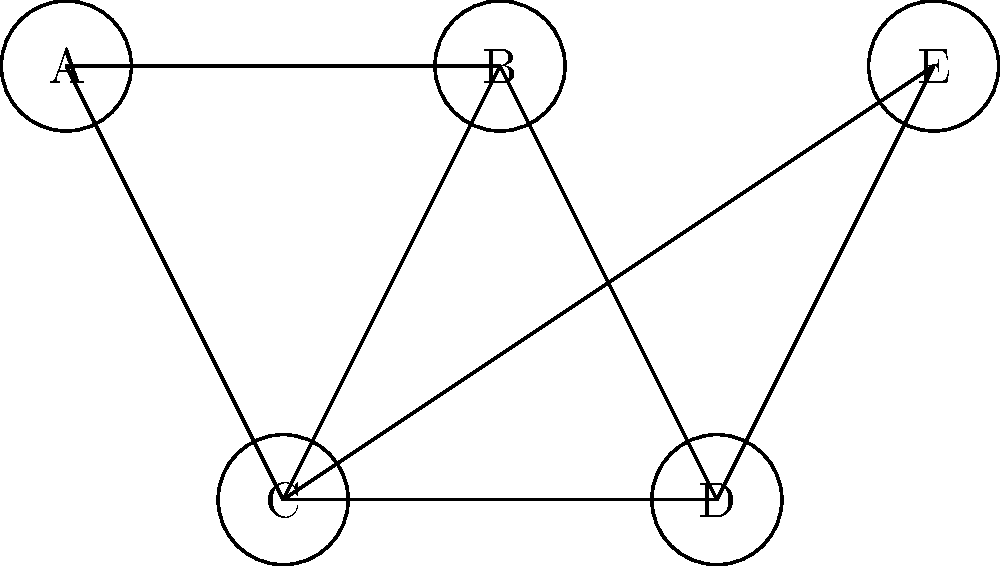You are optimizing a social media content scheduling system using graph coloring. The graph represents conflicts between different types of content, where connected nodes cannot be scheduled in the same time slot. What is the minimum number of colors (time slots) needed to color this graph, ensuring no adjacent nodes have the same color? To solve this graph coloring problem, we'll follow these steps:

1. Understand the graph:
   - Nodes represent different types of content
   - Edges represent conflicts (cannot be scheduled together)

2. Apply the greedy coloring algorithm:
   - Start with node A and assign it color 1
   - Move to node B, assign color 2 (can't use 1 due to connection with A)
   - For node C:
     - Connected to A and B, so can't use colors 1 or 2
     - Assign color 3
   - For node D:
     - Connected to B and C, but not A
     - Can use color 1
   - For node E:
     - Connected to A and C, but not B
     - Can use color 2

3. Count the number of colors used:
   - We used colors 1, 2, and 3

4. Verify that no adjacent nodes have the same color:
   - A (1) - B (2) - C (3) - D (1) - E (2)
   - A (1) - C (3) - E (2)
   - B (2) - D (1)

5. Conclude that 3 colors (time slots) are the minimum needed to properly color this graph.

This coloring ensures that conflicting content types are scheduled in different time slots, optimizing the social media content scheduling system.
Answer: 3 colors (time slots) 